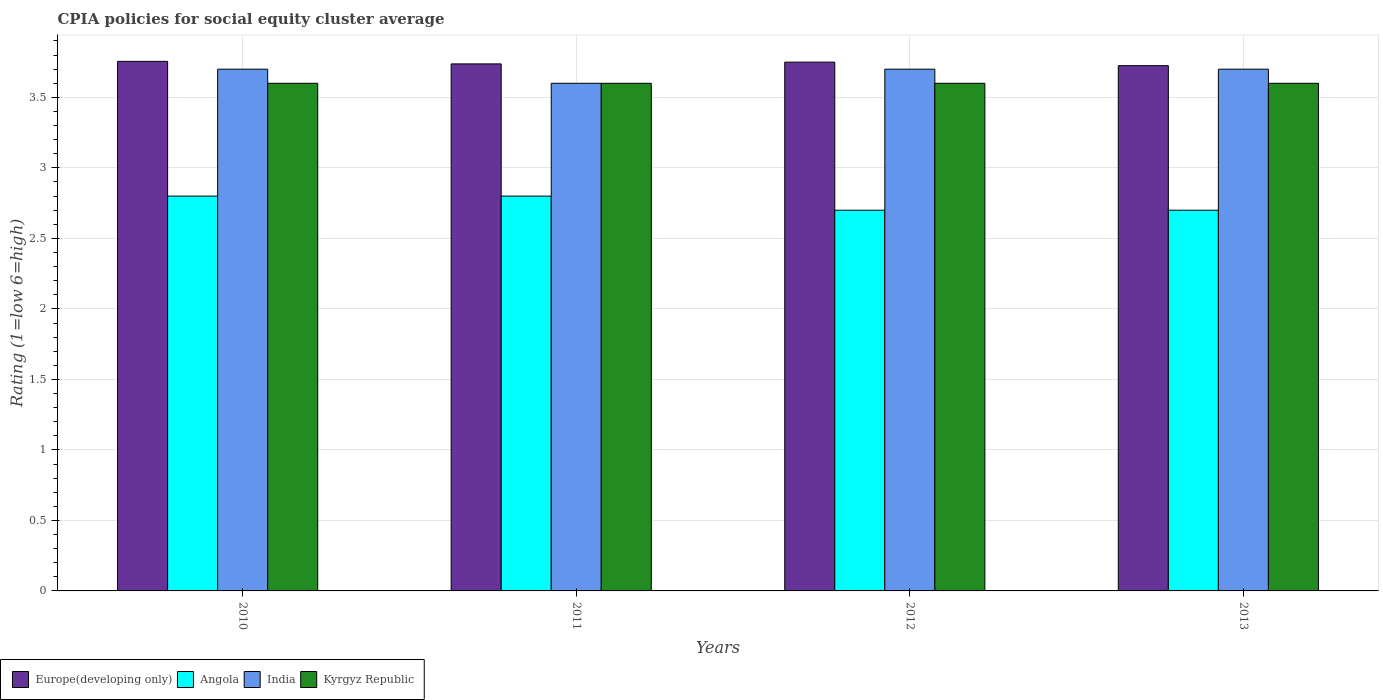How many different coloured bars are there?
Ensure brevity in your answer.  4. Are the number of bars per tick equal to the number of legend labels?
Offer a terse response. Yes. Are the number of bars on each tick of the X-axis equal?
Your response must be concise. Yes. In how many cases, is the number of bars for a given year not equal to the number of legend labels?
Your answer should be compact. 0. What is the CPIA rating in India in 2012?
Keep it short and to the point. 3.7. Across all years, what is the maximum CPIA rating in India?
Offer a very short reply. 3.7. Across all years, what is the minimum CPIA rating in Europe(developing only)?
Ensure brevity in your answer.  3.73. In which year was the CPIA rating in Angola maximum?
Provide a short and direct response. 2010. In which year was the CPIA rating in Kyrgyz Republic minimum?
Provide a short and direct response. 2010. What is the difference between the CPIA rating in Europe(developing only) in 2010 and that in 2011?
Offer a very short reply. 0.02. What is the difference between the CPIA rating in Kyrgyz Republic in 2011 and the CPIA rating in Europe(developing only) in 2010?
Your response must be concise. -0.16. What is the average CPIA rating in Kyrgyz Republic per year?
Make the answer very short. 3.6. In the year 2012, what is the difference between the CPIA rating in Kyrgyz Republic and CPIA rating in Europe(developing only)?
Your answer should be compact. -0.15. In how many years, is the CPIA rating in India greater than 1.7?
Keep it short and to the point. 4. What is the ratio of the CPIA rating in Kyrgyz Republic in 2010 to that in 2012?
Provide a succinct answer. 1. What is the difference between the highest and the second highest CPIA rating in Europe(developing only)?
Provide a short and direct response. 0.01. What is the difference between the highest and the lowest CPIA rating in Europe(developing only)?
Provide a succinct answer. 0.03. In how many years, is the CPIA rating in Kyrgyz Republic greater than the average CPIA rating in Kyrgyz Republic taken over all years?
Make the answer very short. 0. Is it the case that in every year, the sum of the CPIA rating in Kyrgyz Republic and CPIA rating in India is greater than the sum of CPIA rating in Europe(developing only) and CPIA rating in Angola?
Offer a very short reply. No. What does the 3rd bar from the left in 2012 represents?
Offer a terse response. India. What does the 4th bar from the right in 2012 represents?
Provide a short and direct response. Europe(developing only). Is it the case that in every year, the sum of the CPIA rating in Kyrgyz Republic and CPIA rating in Europe(developing only) is greater than the CPIA rating in Angola?
Provide a short and direct response. Yes. How many years are there in the graph?
Provide a short and direct response. 4. What is the difference between two consecutive major ticks on the Y-axis?
Make the answer very short. 0.5. Are the values on the major ticks of Y-axis written in scientific E-notation?
Provide a succinct answer. No. Does the graph contain grids?
Offer a terse response. Yes. Where does the legend appear in the graph?
Provide a succinct answer. Bottom left. How many legend labels are there?
Offer a very short reply. 4. What is the title of the graph?
Offer a very short reply. CPIA policies for social equity cluster average. Does "Latin America(all income levels)" appear as one of the legend labels in the graph?
Offer a very short reply. No. What is the label or title of the X-axis?
Keep it short and to the point. Years. What is the Rating (1=low 6=high) of Europe(developing only) in 2010?
Provide a succinct answer. 3.76. What is the Rating (1=low 6=high) in India in 2010?
Give a very brief answer. 3.7. What is the Rating (1=low 6=high) of Kyrgyz Republic in 2010?
Provide a short and direct response. 3.6. What is the Rating (1=low 6=high) in Europe(developing only) in 2011?
Offer a very short reply. 3.74. What is the Rating (1=low 6=high) in India in 2011?
Give a very brief answer. 3.6. What is the Rating (1=low 6=high) in Europe(developing only) in 2012?
Ensure brevity in your answer.  3.75. What is the Rating (1=low 6=high) in Europe(developing only) in 2013?
Your answer should be very brief. 3.73. What is the Rating (1=low 6=high) of India in 2013?
Offer a terse response. 3.7. What is the Rating (1=low 6=high) of Kyrgyz Republic in 2013?
Offer a very short reply. 3.6. Across all years, what is the maximum Rating (1=low 6=high) of Europe(developing only)?
Your answer should be very brief. 3.76. Across all years, what is the maximum Rating (1=low 6=high) in Angola?
Give a very brief answer. 2.8. Across all years, what is the maximum Rating (1=low 6=high) of Kyrgyz Republic?
Offer a terse response. 3.6. Across all years, what is the minimum Rating (1=low 6=high) in Europe(developing only)?
Provide a succinct answer. 3.73. Across all years, what is the minimum Rating (1=low 6=high) in India?
Make the answer very short. 3.6. What is the total Rating (1=low 6=high) in Europe(developing only) in the graph?
Ensure brevity in your answer.  14.97. What is the total Rating (1=low 6=high) in Angola in the graph?
Your response must be concise. 11. What is the total Rating (1=low 6=high) in India in the graph?
Offer a terse response. 14.7. What is the difference between the Rating (1=low 6=high) of Europe(developing only) in 2010 and that in 2011?
Your answer should be very brief. 0.02. What is the difference between the Rating (1=low 6=high) of Kyrgyz Republic in 2010 and that in 2011?
Your answer should be very brief. 0. What is the difference between the Rating (1=low 6=high) in Europe(developing only) in 2010 and that in 2012?
Offer a terse response. 0.01. What is the difference between the Rating (1=low 6=high) in India in 2010 and that in 2012?
Make the answer very short. 0. What is the difference between the Rating (1=low 6=high) of Kyrgyz Republic in 2010 and that in 2012?
Keep it short and to the point. 0. What is the difference between the Rating (1=low 6=high) of Europe(developing only) in 2010 and that in 2013?
Keep it short and to the point. 0.03. What is the difference between the Rating (1=low 6=high) of Kyrgyz Republic in 2010 and that in 2013?
Give a very brief answer. 0. What is the difference between the Rating (1=low 6=high) in Europe(developing only) in 2011 and that in 2012?
Ensure brevity in your answer.  -0.01. What is the difference between the Rating (1=low 6=high) of Angola in 2011 and that in 2012?
Your response must be concise. 0.1. What is the difference between the Rating (1=low 6=high) in India in 2011 and that in 2012?
Your answer should be compact. -0.1. What is the difference between the Rating (1=low 6=high) of Kyrgyz Republic in 2011 and that in 2012?
Provide a short and direct response. 0. What is the difference between the Rating (1=low 6=high) in Europe(developing only) in 2011 and that in 2013?
Provide a succinct answer. 0.01. What is the difference between the Rating (1=low 6=high) of India in 2011 and that in 2013?
Your answer should be compact. -0.1. What is the difference between the Rating (1=low 6=high) of Kyrgyz Republic in 2011 and that in 2013?
Make the answer very short. 0. What is the difference between the Rating (1=low 6=high) of Europe(developing only) in 2012 and that in 2013?
Make the answer very short. 0.03. What is the difference between the Rating (1=low 6=high) in Europe(developing only) in 2010 and the Rating (1=low 6=high) in Angola in 2011?
Your answer should be very brief. 0.96. What is the difference between the Rating (1=low 6=high) of Europe(developing only) in 2010 and the Rating (1=low 6=high) of India in 2011?
Offer a very short reply. 0.16. What is the difference between the Rating (1=low 6=high) in Europe(developing only) in 2010 and the Rating (1=low 6=high) in Kyrgyz Republic in 2011?
Your answer should be compact. 0.16. What is the difference between the Rating (1=low 6=high) in Angola in 2010 and the Rating (1=low 6=high) in India in 2011?
Your answer should be compact. -0.8. What is the difference between the Rating (1=low 6=high) in Angola in 2010 and the Rating (1=low 6=high) in Kyrgyz Republic in 2011?
Ensure brevity in your answer.  -0.8. What is the difference between the Rating (1=low 6=high) in Europe(developing only) in 2010 and the Rating (1=low 6=high) in Angola in 2012?
Your answer should be very brief. 1.06. What is the difference between the Rating (1=low 6=high) in Europe(developing only) in 2010 and the Rating (1=low 6=high) in India in 2012?
Make the answer very short. 0.06. What is the difference between the Rating (1=low 6=high) of Europe(developing only) in 2010 and the Rating (1=low 6=high) of Kyrgyz Republic in 2012?
Your response must be concise. 0.16. What is the difference between the Rating (1=low 6=high) of Angola in 2010 and the Rating (1=low 6=high) of Kyrgyz Republic in 2012?
Give a very brief answer. -0.8. What is the difference between the Rating (1=low 6=high) of India in 2010 and the Rating (1=low 6=high) of Kyrgyz Republic in 2012?
Ensure brevity in your answer.  0.1. What is the difference between the Rating (1=low 6=high) of Europe(developing only) in 2010 and the Rating (1=low 6=high) of Angola in 2013?
Provide a short and direct response. 1.06. What is the difference between the Rating (1=low 6=high) of Europe(developing only) in 2010 and the Rating (1=low 6=high) of India in 2013?
Ensure brevity in your answer.  0.06. What is the difference between the Rating (1=low 6=high) in Europe(developing only) in 2010 and the Rating (1=low 6=high) in Kyrgyz Republic in 2013?
Offer a very short reply. 0.16. What is the difference between the Rating (1=low 6=high) of Angola in 2010 and the Rating (1=low 6=high) of Kyrgyz Republic in 2013?
Keep it short and to the point. -0.8. What is the difference between the Rating (1=low 6=high) in India in 2010 and the Rating (1=low 6=high) in Kyrgyz Republic in 2013?
Your response must be concise. 0.1. What is the difference between the Rating (1=low 6=high) of Europe(developing only) in 2011 and the Rating (1=low 6=high) of Angola in 2012?
Offer a terse response. 1.04. What is the difference between the Rating (1=low 6=high) of Europe(developing only) in 2011 and the Rating (1=low 6=high) of India in 2012?
Keep it short and to the point. 0.04. What is the difference between the Rating (1=low 6=high) in Europe(developing only) in 2011 and the Rating (1=low 6=high) in Kyrgyz Republic in 2012?
Provide a succinct answer. 0.14. What is the difference between the Rating (1=low 6=high) in Angola in 2011 and the Rating (1=low 6=high) in India in 2012?
Make the answer very short. -0.9. What is the difference between the Rating (1=low 6=high) of Europe(developing only) in 2011 and the Rating (1=low 6=high) of Angola in 2013?
Provide a succinct answer. 1.04. What is the difference between the Rating (1=low 6=high) of Europe(developing only) in 2011 and the Rating (1=low 6=high) of India in 2013?
Your response must be concise. 0.04. What is the difference between the Rating (1=low 6=high) of Europe(developing only) in 2011 and the Rating (1=low 6=high) of Kyrgyz Republic in 2013?
Your answer should be compact. 0.14. What is the difference between the Rating (1=low 6=high) in India in 2011 and the Rating (1=low 6=high) in Kyrgyz Republic in 2013?
Your answer should be very brief. 0. What is the difference between the Rating (1=low 6=high) in Europe(developing only) in 2012 and the Rating (1=low 6=high) in India in 2013?
Offer a terse response. 0.05. What is the difference between the Rating (1=low 6=high) in Europe(developing only) in 2012 and the Rating (1=low 6=high) in Kyrgyz Republic in 2013?
Your answer should be compact. 0.15. What is the difference between the Rating (1=low 6=high) in Angola in 2012 and the Rating (1=low 6=high) in India in 2013?
Provide a succinct answer. -1. What is the average Rating (1=low 6=high) of Europe(developing only) per year?
Provide a succinct answer. 3.74. What is the average Rating (1=low 6=high) in Angola per year?
Make the answer very short. 2.75. What is the average Rating (1=low 6=high) in India per year?
Provide a succinct answer. 3.67. In the year 2010, what is the difference between the Rating (1=low 6=high) of Europe(developing only) and Rating (1=low 6=high) of Angola?
Ensure brevity in your answer.  0.96. In the year 2010, what is the difference between the Rating (1=low 6=high) in Europe(developing only) and Rating (1=low 6=high) in India?
Offer a very short reply. 0.06. In the year 2010, what is the difference between the Rating (1=low 6=high) of Europe(developing only) and Rating (1=low 6=high) of Kyrgyz Republic?
Give a very brief answer. 0.16. In the year 2010, what is the difference between the Rating (1=low 6=high) in Angola and Rating (1=low 6=high) in India?
Keep it short and to the point. -0.9. In the year 2010, what is the difference between the Rating (1=low 6=high) of India and Rating (1=low 6=high) of Kyrgyz Republic?
Keep it short and to the point. 0.1. In the year 2011, what is the difference between the Rating (1=low 6=high) in Europe(developing only) and Rating (1=low 6=high) in Angola?
Offer a very short reply. 0.94. In the year 2011, what is the difference between the Rating (1=low 6=high) of Europe(developing only) and Rating (1=low 6=high) of India?
Ensure brevity in your answer.  0.14. In the year 2011, what is the difference between the Rating (1=low 6=high) in Europe(developing only) and Rating (1=low 6=high) in Kyrgyz Republic?
Keep it short and to the point. 0.14. In the year 2011, what is the difference between the Rating (1=low 6=high) of Angola and Rating (1=low 6=high) of India?
Your response must be concise. -0.8. In the year 2011, what is the difference between the Rating (1=low 6=high) of Angola and Rating (1=low 6=high) of Kyrgyz Republic?
Offer a very short reply. -0.8. In the year 2012, what is the difference between the Rating (1=low 6=high) of Europe(developing only) and Rating (1=low 6=high) of Angola?
Provide a succinct answer. 1.05. In the year 2012, what is the difference between the Rating (1=low 6=high) in Europe(developing only) and Rating (1=low 6=high) in India?
Your response must be concise. 0.05. In the year 2012, what is the difference between the Rating (1=low 6=high) of Angola and Rating (1=low 6=high) of India?
Give a very brief answer. -1. In the year 2012, what is the difference between the Rating (1=low 6=high) of Angola and Rating (1=low 6=high) of Kyrgyz Republic?
Give a very brief answer. -0.9. In the year 2012, what is the difference between the Rating (1=low 6=high) of India and Rating (1=low 6=high) of Kyrgyz Republic?
Offer a very short reply. 0.1. In the year 2013, what is the difference between the Rating (1=low 6=high) of Europe(developing only) and Rating (1=low 6=high) of India?
Give a very brief answer. 0.03. In the year 2013, what is the difference between the Rating (1=low 6=high) in Europe(developing only) and Rating (1=low 6=high) in Kyrgyz Republic?
Provide a succinct answer. 0.12. In the year 2013, what is the difference between the Rating (1=low 6=high) of India and Rating (1=low 6=high) of Kyrgyz Republic?
Offer a very short reply. 0.1. What is the ratio of the Rating (1=low 6=high) in Angola in 2010 to that in 2011?
Ensure brevity in your answer.  1. What is the ratio of the Rating (1=low 6=high) of India in 2010 to that in 2011?
Provide a short and direct response. 1.03. What is the ratio of the Rating (1=low 6=high) of Europe(developing only) in 2010 to that in 2012?
Your answer should be very brief. 1. What is the ratio of the Rating (1=low 6=high) in Angola in 2010 to that in 2012?
Your answer should be compact. 1.04. What is the ratio of the Rating (1=low 6=high) of Kyrgyz Republic in 2010 to that in 2012?
Offer a terse response. 1. What is the ratio of the Rating (1=low 6=high) in Europe(developing only) in 2010 to that in 2013?
Give a very brief answer. 1.01. What is the ratio of the Rating (1=low 6=high) in Angola in 2010 to that in 2013?
Provide a short and direct response. 1.04. What is the ratio of the Rating (1=low 6=high) of Angola in 2011 to that in 2012?
Offer a terse response. 1.04. What is the ratio of the Rating (1=low 6=high) of Europe(developing only) in 2012 to that in 2013?
Make the answer very short. 1.01. What is the ratio of the Rating (1=low 6=high) in Angola in 2012 to that in 2013?
Provide a short and direct response. 1. What is the ratio of the Rating (1=low 6=high) in Kyrgyz Republic in 2012 to that in 2013?
Keep it short and to the point. 1. What is the difference between the highest and the second highest Rating (1=low 6=high) in Europe(developing only)?
Provide a short and direct response. 0.01. What is the difference between the highest and the second highest Rating (1=low 6=high) of Angola?
Give a very brief answer. 0. What is the difference between the highest and the second highest Rating (1=low 6=high) of Kyrgyz Republic?
Your answer should be compact. 0. What is the difference between the highest and the lowest Rating (1=low 6=high) in Europe(developing only)?
Your answer should be very brief. 0.03. What is the difference between the highest and the lowest Rating (1=low 6=high) of Angola?
Your answer should be compact. 0.1. 